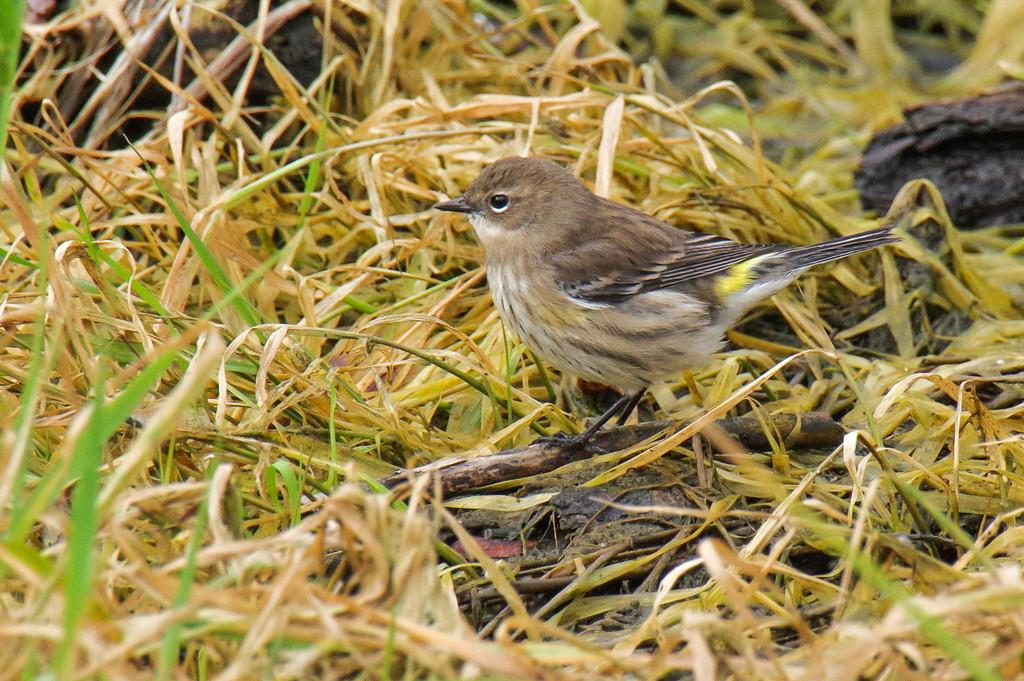What type of animal can be seen in the image? There is a bird in the image. Where is the bird positioned in the image? The bird is standing on a stem. What type of vegetation is present in the image? There is grass in the image. What type of terrain is visible in the image? There is mud in the image. What color are the hands of the bird in the image? There are no hands visible on the bird in the image, as birds do not have hands. 